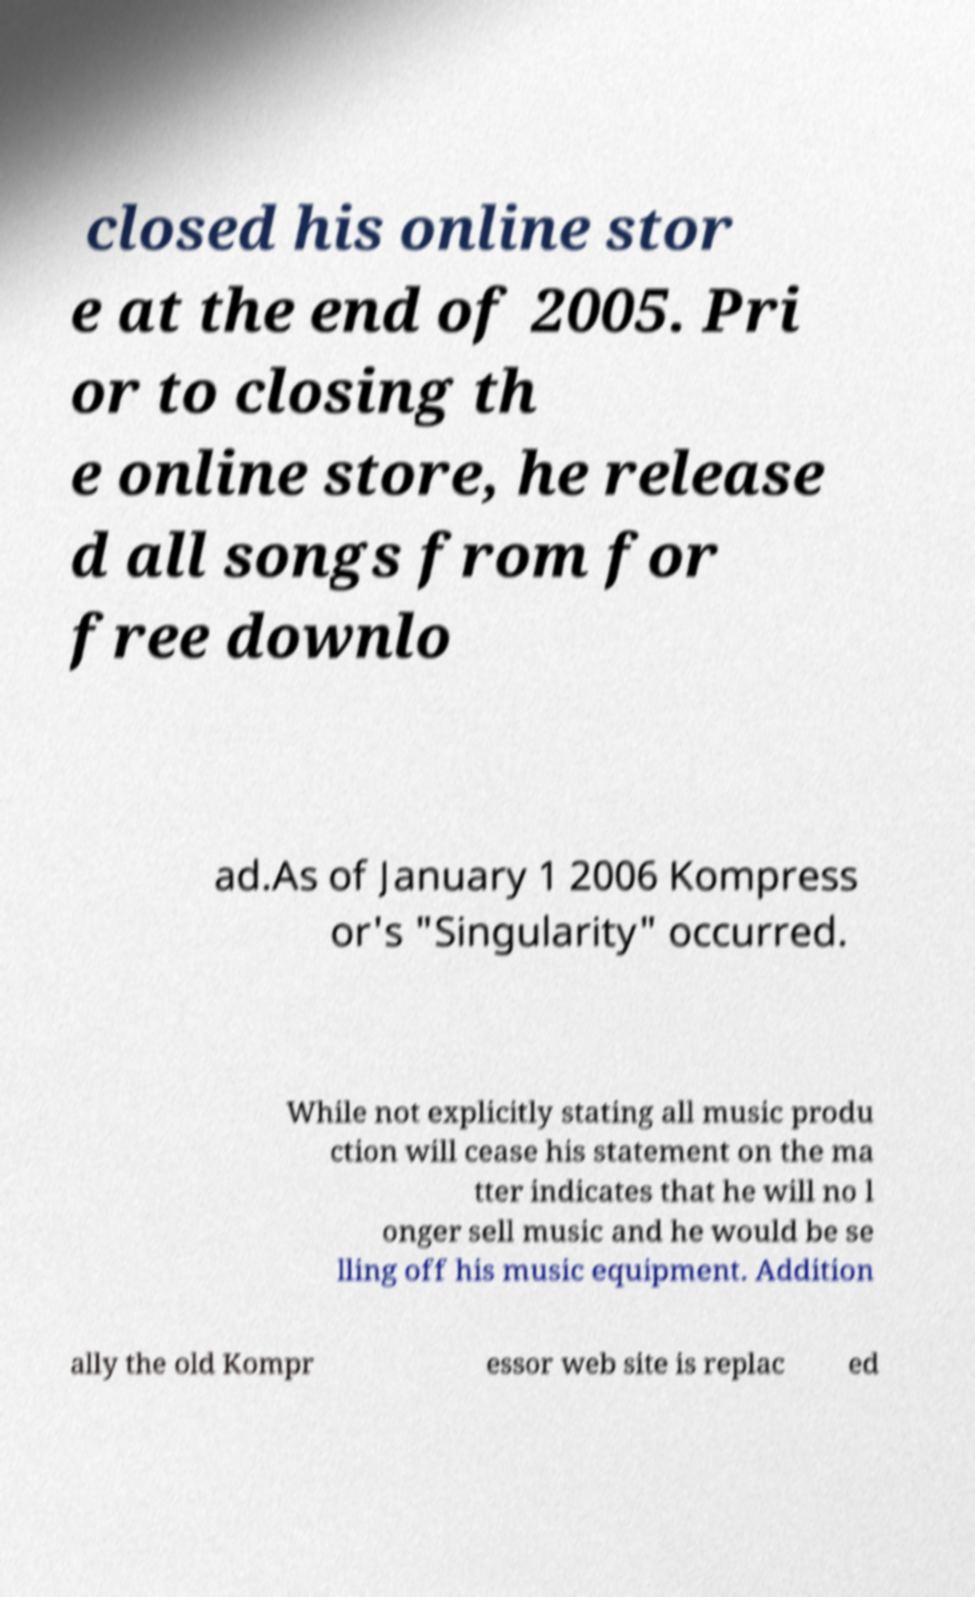For documentation purposes, I need the text within this image transcribed. Could you provide that? closed his online stor e at the end of 2005. Pri or to closing th e online store, he release d all songs from for free downlo ad.As of January 1 2006 Kompress or's "Singularity" occurred. While not explicitly stating all music produ ction will cease his statement on the ma tter indicates that he will no l onger sell music and he would be se lling off his music equipment. Addition ally the old Kompr essor web site is replac ed 